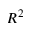Convert formula to latex. <formula><loc_0><loc_0><loc_500><loc_500>R ^ { 2 }</formula> 